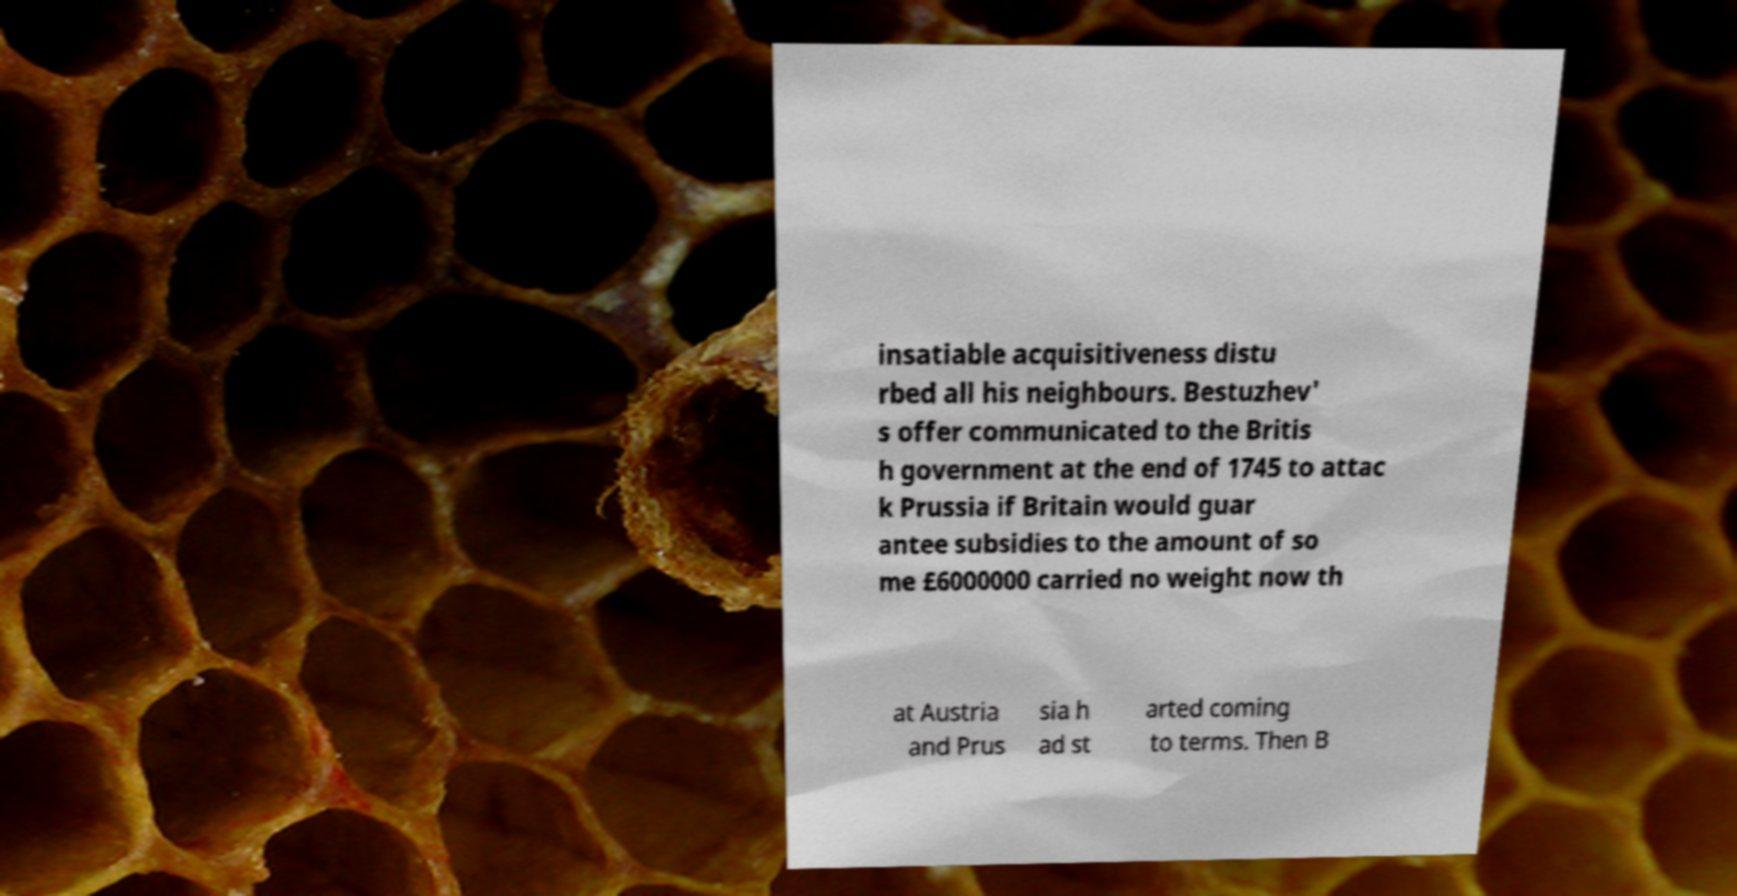For documentation purposes, I need the text within this image transcribed. Could you provide that? insatiable acquisitiveness distu rbed all his neighbours. Bestuzhev' s offer communicated to the Britis h government at the end of 1745 to attac k Prussia if Britain would guar antee subsidies to the amount of so me £6000000 carried no weight now th at Austria and Prus sia h ad st arted coming to terms. Then B 